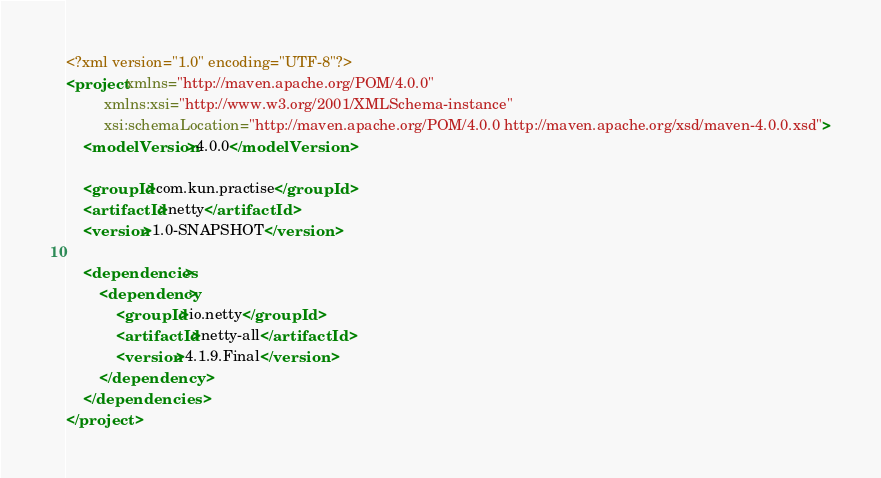<code> <loc_0><loc_0><loc_500><loc_500><_XML_><?xml version="1.0" encoding="UTF-8"?>
<project xmlns="http://maven.apache.org/POM/4.0.0"
         xmlns:xsi="http://www.w3.org/2001/XMLSchema-instance"
         xsi:schemaLocation="http://maven.apache.org/POM/4.0.0 http://maven.apache.org/xsd/maven-4.0.0.xsd">
    <modelVersion>4.0.0</modelVersion>

    <groupId>com.kun.practise</groupId>
    <artifactId>netty</artifactId>
    <version>1.0-SNAPSHOT</version>

    <dependencies>
        <dependency>
            <groupId>io.netty</groupId>
            <artifactId>netty-all</artifactId>
            <version>4.1.9.Final</version>
        </dependency>
    </dependencies>
</project></code> 